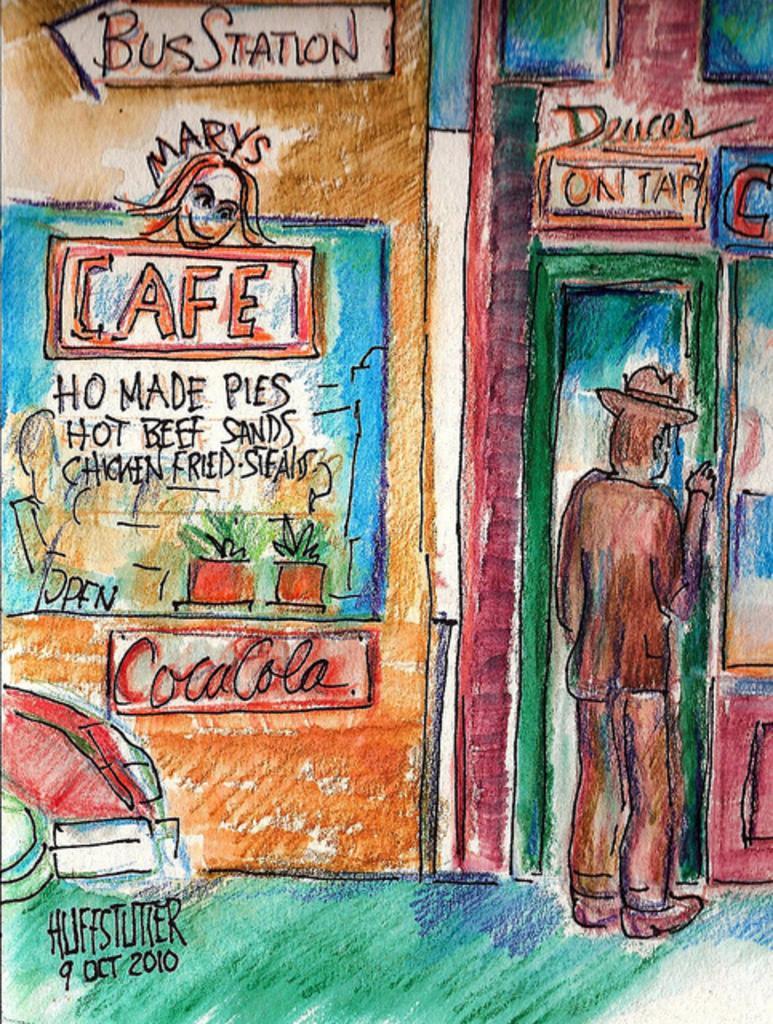Can you describe this image briefly? In this image, we can see a painting. 